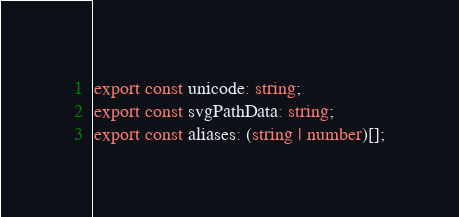<code> <loc_0><loc_0><loc_500><loc_500><_TypeScript_>export const unicode: string;
export const svgPathData: string;
export const aliases: (string | number)[];</code> 